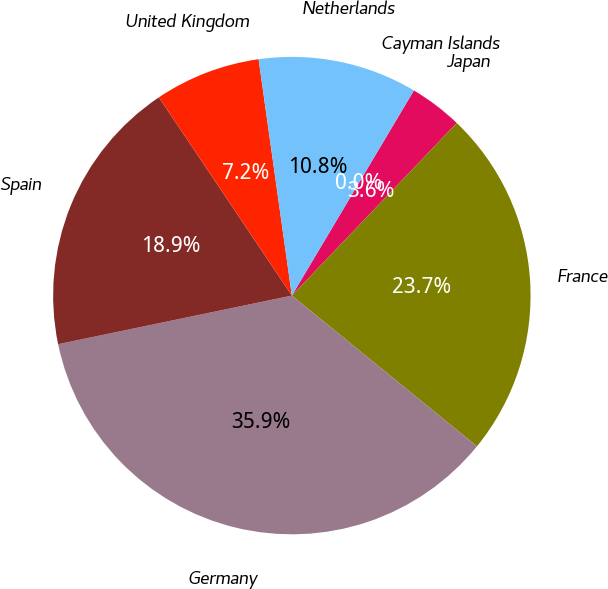Convert chart. <chart><loc_0><loc_0><loc_500><loc_500><pie_chart><fcel>Cayman Islands<fcel>Japan<fcel>France<fcel>Germany<fcel>Spain<fcel>United Kingdom<fcel>Netherlands<nl><fcel>0.01%<fcel>3.59%<fcel>23.74%<fcel>35.86%<fcel>18.86%<fcel>7.18%<fcel>10.76%<nl></chart> 